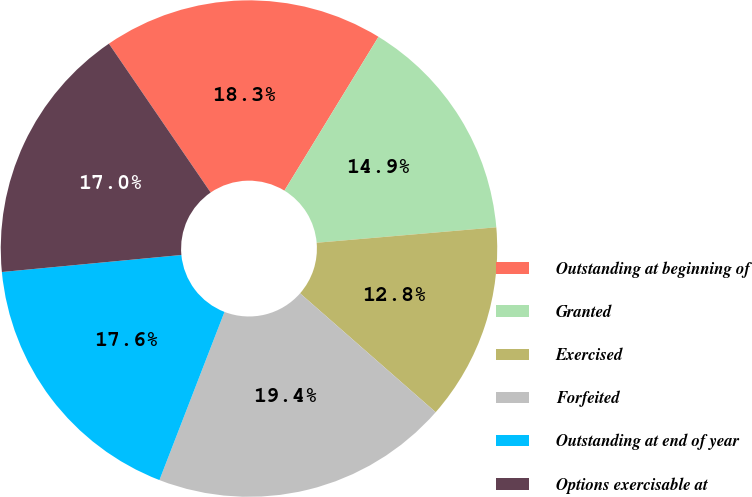<chart> <loc_0><loc_0><loc_500><loc_500><pie_chart><fcel>Outstanding at beginning of<fcel>Granted<fcel>Exercised<fcel>Forfeited<fcel>Outstanding at end of year<fcel>Options exercisable at<nl><fcel>18.28%<fcel>14.9%<fcel>12.82%<fcel>19.42%<fcel>17.62%<fcel>16.96%<nl></chart> 